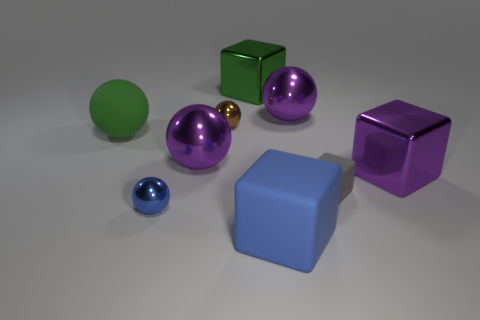Subtract 1 balls. How many balls are left? 4 Subtract all red spheres. Subtract all purple cylinders. How many spheres are left? 5 Add 1 small rubber things. How many objects exist? 10 Subtract all blocks. How many objects are left? 5 Subtract all green shiny cubes. Subtract all large green objects. How many objects are left? 6 Add 3 green metallic cubes. How many green metallic cubes are left? 4 Add 1 tiny brown spheres. How many tiny brown spheres exist? 2 Subtract 0 red balls. How many objects are left? 9 